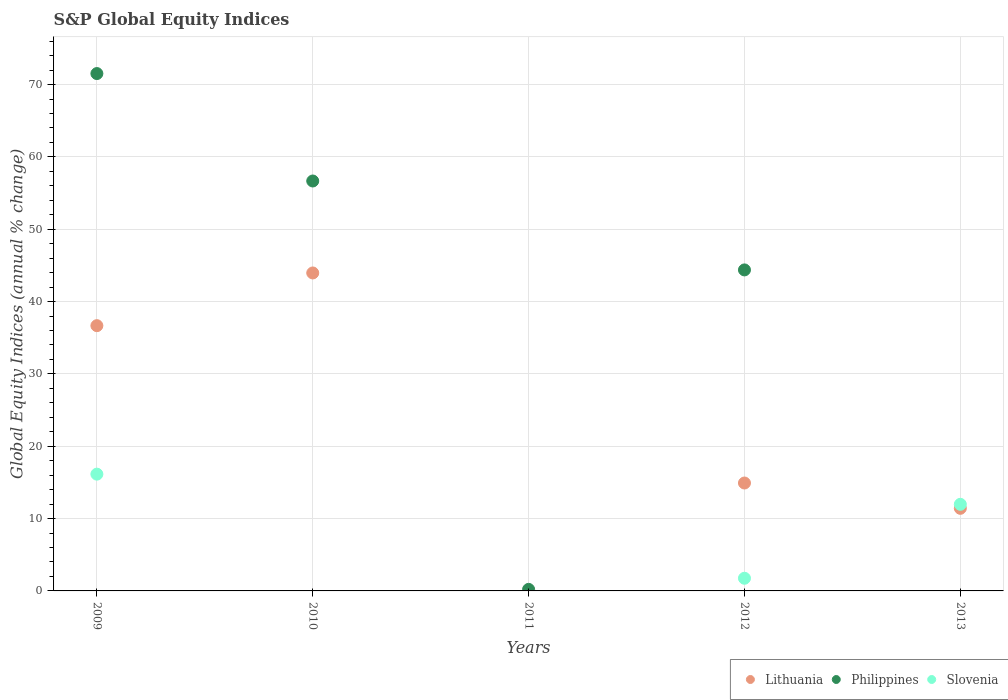What is the global equity indices in Slovenia in 2009?
Your answer should be very brief. 16.14. Across all years, what is the maximum global equity indices in Philippines?
Ensure brevity in your answer.  71.52. Across all years, what is the minimum global equity indices in Philippines?
Give a very brief answer. 0. In which year was the global equity indices in Philippines maximum?
Offer a very short reply. 2009. What is the total global equity indices in Lithuania in the graph?
Offer a very short reply. 106.96. What is the difference between the global equity indices in Lithuania in 2010 and that in 2013?
Offer a terse response. 32.54. What is the difference between the global equity indices in Philippines in 2010 and the global equity indices in Slovenia in 2009?
Offer a terse response. 40.53. What is the average global equity indices in Lithuania per year?
Provide a short and direct response. 21.39. In the year 2009, what is the difference between the global equity indices in Slovenia and global equity indices in Philippines?
Ensure brevity in your answer.  -55.38. What is the ratio of the global equity indices in Philippines in 2011 to that in 2012?
Provide a succinct answer. 0. Is the global equity indices in Lithuania in 2009 less than that in 2013?
Offer a terse response. No. What is the difference between the highest and the second highest global equity indices in Philippines?
Provide a short and direct response. 14.85. What is the difference between the highest and the lowest global equity indices in Slovenia?
Offer a very short reply. 16.14. In how many years, is the global equity indices in Lithuania greater than the average global equity indices in Lithuania taken over all years?
Keep it short and to the point. 2. Does the global equity indices in Slovenia monotonically increase over the years?
Ensure brevity in your answer.  No. How many dotlines are there?
Provide a succinct answer. 3. Does the graph contain any zero values?
Your answer should be very brief. Yes. Does the graph contain grids?
Your answer should be very brief. Yes. How many legend labels are there?
Offer a terse response. 3. What is the title of the graph?
Offer a very short reply. S&P Global Equity Indices. What is the label or title of the X-axis?
Make the answer very short. Years. What is the label or title of the Y-axis?
Offer a very short reply. Global Equity Indices (annual % change). What is the Global Equity Indices (annual % change) of Lithuania in 2009?
Ensure brevity in your answer.  36.67. What is the Global Equity Indices (annual % change) in Philippines in 2009?
Offer a very short reply. 71.52. What is the Global Equity Indices (annual % change) in Slovenia in 2009?
Make the answer very short. 16.14. What is the Global Equity Indices (annual % change) in Lithuania in 2010?
Give a very brief answer. 43.96. What is the Global Equity Indices (annual % change) of Philippines in 2010?
Ensure brevity in your answer.  56.67. What is the Global Equity Indices (annual % change) in Slovenia in 2010?
Your response must be concise. 0. What is the Global Equity Indices (annual % change) of Philippines in 2011?
Ensure brevity in your answer.  0.22. What is the Global Equity Indices (annual % change) of Slovenia in 2011?
Offer a terse response. 0. What is the Global Equity Indices (annual % change) of Lithuania in 2012?
Your response must be concise. 14.92. What is the Global Equity Indices (annual % change) of Philippines in 2012?
Your answer should be very brief. 44.38. What is the Global Equity Indices (annual % change) in Slovenia in 2012?
Your answer should be very brief. 1.75. What is the Global Equity Indices (annual % change) of Lithuania in 2013?
Offer a terse response. 11.42. What is the Global Equity Indices (annual % change) in Slovenia in 2013?
Provide a short and direct response. 11.97. Across all years, what is the maximum Global Equity Indices (annual % change) in Lithuania?
Your response must be concise. 43.96. Across all years, what is the maximum Global Equity Indices (annual % change) of Philippines?
Your response must be concise. 71.52. Across all years, what is the maximum Global Equity Indices (annual % change) in Slovenia?
Your response must be concise. 16.14. Across all years, what is the minimum Global Equity Indices (annual % change) of Lithuania?
Ensure brevity in your answer.  0. Across all years, what is the minimum Global Equity Indices (annual % change) of Philippines?
Offer a terse response. 0. What is the total Global Equity Indices (annual % change) in Lithuania in the graph?
Your answer should be compact. 106.96. What is the total Global Equity Indices (annual % change) of Philippines in the graph?
Make the answer very short. 172.78. What is the total Global Equity Indices (annual % change) in Slovenia in the graph?
Ensure brevity in your answer.  29.87. What is the difference between the Global Equity Indices (annual % change) of Lithuania in 2009 and that in 2010?
Ensure brevity in your answer.  -7.29. What is the difference between the Global Equity Indices (annual % change) in Philippines in 2009 and that in 2010?
Your answer should be compact. 14.85. What is the difference between the Global Equity Indices (annual % change) of Philippines in 2009 and that in 2011?
Ensure brevity in your answer.  71.31. What is the difference between the Global Equity Indices (annual % change) in Lithuania in 2009 and that in 2012?
Your answer should be compact. 21.75. What is the difference between the Global Equity Indices (annual % change) in Philippines in 2009 and that in 2012?
Offer a terse response. 27.14. What is the difference between the Global Equity Indices (annual % change) in Slovenia in 2009 and that in 2012?
Give a very brief answer. 14.39. What is the difference between the Global Equity Indices (annual % change) of Lithuania in 2009 and that in 2013?
Provide a succinct answer. 25.25. What is the difference between the Global Equity Indices (annual % change) of Slovenia in 2009 and that in 2013?
Your answer should be very brief. 4.17. What is the difference between the Global Equity Indices (annual % change) of Philippines in 2010 and that in 2011?
Your answer should be compact. 56.45. What is the difference between the Global Equity Indices (annual % change) of Lithuania in 2010 and that in 2012?
Offer a terse response. 29.04. What is the difference between the Global Equity Indices (annual % change) of Philippines in 2010 and that in 2012?
Ensure brevity in your answer.  12.29. What is the difference between the Global Equity Indices (annual % change) of Lithuania in 2010 and that in 2013?
Make the answer very short. 32.54. What is the difference between the Global Equity Indices (annual % change) in Philippines in 2011 and that in 2012?
Ensure brevity in your answer.  -44.16. What is the difference between the Global Equity Indices (annual % change) of Lithuania in 2012 and that in 2013?
Your answer should be very brief. 3.5. What is the difference between the Global Equity Indices (annual % change) of Slovenia in 2012 and that in 2013?
Make the answer very short. -10.22. What is the difference between the Global Equity Indices (annual % change) of Lithuania in 2009 and the Global Equity Indices (annual % change) of Philippines in 2010?
Your answer should be compact. -20. What is the difference between the Global Equity Indices (annual % change) of Lithuania in 2009 and the Global Equity Indices (annual % change) of Philippines in 2011?
Provide a succinct answer. 36.46. What is the difference between the Global Equity Indices (annual % change) in Lithuania in 2009 and the Global Equity Indices (annual % change) in Philippines in 2012?
Your answer should be very brief. -7.71. What is the difference between the Global Equity Indices (annual % change) in Lithuania in 2009 and the Global Equity Indices (annual % change) in Slovenia in 2012?
Provide a succinct answer. 34.92. What is the difference between the Global Equity Indices (annual % change) of Philippines in 2009 and the Global Equity Indices (annual % change) of Slovenia in 2012?
Give a very brief answer. 69.77. What is the difference between the Global Equity Indices (annual % change) of Lithuania in 2009 and the Global Equity Indices (annual % change) of Slovenia in 2013?
Offer a terse response. 24.7. What is the difference between the Global Equity Indices (annual % change) of Philippines in 2009 and the Global Equity Indices (annual % change) of Slovenia in 2013?
Make the answer very short. 59.55. What is the difference between the Global Equity Indices (annual % change) in Lithuania in 2010 and the Global Equity Indices (annual % change) in Philippines in 2011?
Offer a very short reply. 43.74. What is the difference between the Global Equity Indices (annual % change) in Lithuania in 2010 and the Global Equity Indices (annual % change) in Philippines in 2012?
Provide a succinct answer. -0.42. What is the difference between the Global Equity Indices (annual % change) in Lithuania in 2010 and the Global Equity Indices (annual % change) in Slovenia in 2012?
Provide a succinct answer. 42.21. What is the difference between the Global Equity Indices (annual % change) of Philippines in 2010 and the Global Equity Indices (annual % change) of Slovenia in 2012?
Give a very brief answer. 54.92. What is the difference between the Global Equity Indices (annual % change) of Lithuania in 2010 and the Global Equity Indices (annual % change) of Slovenia in 2013?
Your answer should be compact. 31.99. What is the difference between the Global Equity Indices (annual % change) in Philippines in 2010 and the Global Equity Indices (annual % change) in Slovenia in 2013?
Offer a terse response. 44.7. What is the difference between the Global Equity Indices (annual % change) of Philippines in 2011 and the Global Equity Indices (annual % change) of Slovenia in 2012?
Provide a succinct answer. -1.54. What is the difference between the Global Equity Indices (annual % change) of Philippines in 2011 and the Global Equity Indices (annual % change) of Slovenia in 2013?
Make the answer very short. -11.76. What is the difference between the Global Equity Indices (annual % change) of Lithuania in 2012 and the Global Equity Indices (annual % change) of Slovenia in 2013?
Give a very brief answer. 2.95. What is the difference between the Global Equity Indices (annual % change) of Philippines in 2012 and the Global Equity Indices (annual % change) of Slovenia in 2013?
Your answer should be very brief. 32.41. What is the average Global Equity Indices (annual % change) in Lithuania per year?
Offer a terse response. 21.39. What is the average Global Equity Indices (annual % change) in Philippines per year?
Offer a terse response. 34.56. What is the average Global Equity Indices (annual % change) in Slovenia per year?
Keep it short and to the point. 5.97. In the year 2009, what is the difference between the Global Equity Indices (annual % change) in Lithuania and Global Equity Indices (annual % change) in Philippines?
Your answer should be very brief. -34.85. In the year 2009, what is the difference between the Global Equity Indices (annual % change) of Lithuania and Global Equity Indices (annual % change) of Slovenia?
Provide a short and direct response. 20.53. In the year 2009, what is the difference between the Global Equity Indices (annual % change) in Philippines and Global Equity Indices (annual % change) in Slovenia?
Your answer should be compact. 55.38. In the year 2010, what is the difference between the Global Equity Indices (annual % change) in Lithuania and Global Equity Indices (annual % change) in Philippines?
Your answer should be compact. -12.71. In the year 2012, what is the difference between the Global Equity Indices (annual % change) in Lithuania and Global Equity Indices (annual % change) in Philippines?
Provide a succinct answer. -29.46. In the year 2012, what is the difference between the Global Equity Indices (annual % change) in Lithuania and Global Equity Indices (annual % change) in Slovenia?
Make the answer very short. 13.17. In the year 2012, what is the difference between the Global Equity Indices (annual % change) in Philippines and Global Equity Indices (annual % change) in Slovenia?
Your answer should be very brief. 42.63. In the year 2013, what is the difference between the Global Equity Indices (annual % change) of Lithuania and Global Equity Indices (annual % change) of Slovenia?
Your answer should be very brief. -0.55. What is the ratio of the Global Equity Indices (annual % change) of Lithuania in 2009 to that in 2010?
Offer a terse response. 0.83. What is the ratio of the Global Equity Indices (annual % change) of Philippines in 2009 to that in 2010?
Your answer should be compact. 1.26. What is the ratio of the Global Equity Indices (annual % change) in Philippines in 2009 to that in 2011?
Your answer should be very brief. 332.53. What is the ratio of the Global Equity Indices (annual % change) in Lithuania in 2009 to that in 2012?
Provide a short and direct response. 2.46. What is the ratio of the Global Equity Indices (annual % change) in Philippines in 2009 to that in 2012?
Offer a terse response. 1.61. What is the ratio of the Global Equity Indices (annual % change) of Slovenia in 2009 to that in 2012?
Make the answer very short. 9.22. What is the ratio of the Global Equity Indices (annual % change) of Lithuania in 2009 to that in 2013?
Give a very brief answer. 3.21. What is the ratio of the Global Equity Indices (annual % change) of Slovenia in 2009 to that in 2013?
Make the answer very short. 1.35. What is the ratio of the Global Equity Indices (annual % change) of Philippines in 2010 to that in 2011?
Keep it short and to the point. 263.48. What is the ratio of the Global Equity Indices (annual % change) in Lithuania in 2010 to that in 2012?
Provide a short and direct response. 2.95. What is the ratio of the Global Equity Indices (annual % change) in Philippines in 2010 to that in 2012?
Ensure brevity in your answer.  1.28. What is the ratio of the Global Equity Indices (annual % change) in Lithuania in 2010 to that in 2013?
Give a very brief answer. 3.85. What is the ratio of the Global Equity Indices (annual % change) of Philippines in 2011 to that in 2012?
Provide a succinct answer. 0. What is the ratio of the Global Equity Indices (annual % change) in Lithuania in 2012 to that in 2013?
Provide a short and direct response. 1.31. What is the ratio of the Global Equity Indices (annual % change) of Slovenia in 2012 to that in 2013?
Provide a succinct answer. 0.15. What is the difference between the highest and the second highest Global Equity Indices (annual % change) of Lithuania?
Your answer should be very brief. 7.29. What is the difference between the highest and the second highest Global Equity Indices (annual % change) in Philippines?
Offer a very short reply. 14.85. What is the difference between the highest and the second highest Global Equity Indices (annual % change) in Slovenia?
Offer a terse response. 4.17. What is the difference between the highest and the lowest Global Equity Indices (annual % change) of Lithuania?
Offer a very short reply. 43.96. What is the difference between the highest and the lowest Global Equity Indices (annual % change) of Philippines?
Make the answer very short. 71.52. What is the difference between the highest and the lowest Global Equity Indices (annual % change) of Slovenia?
Provide a succinct answer. 16.14. 